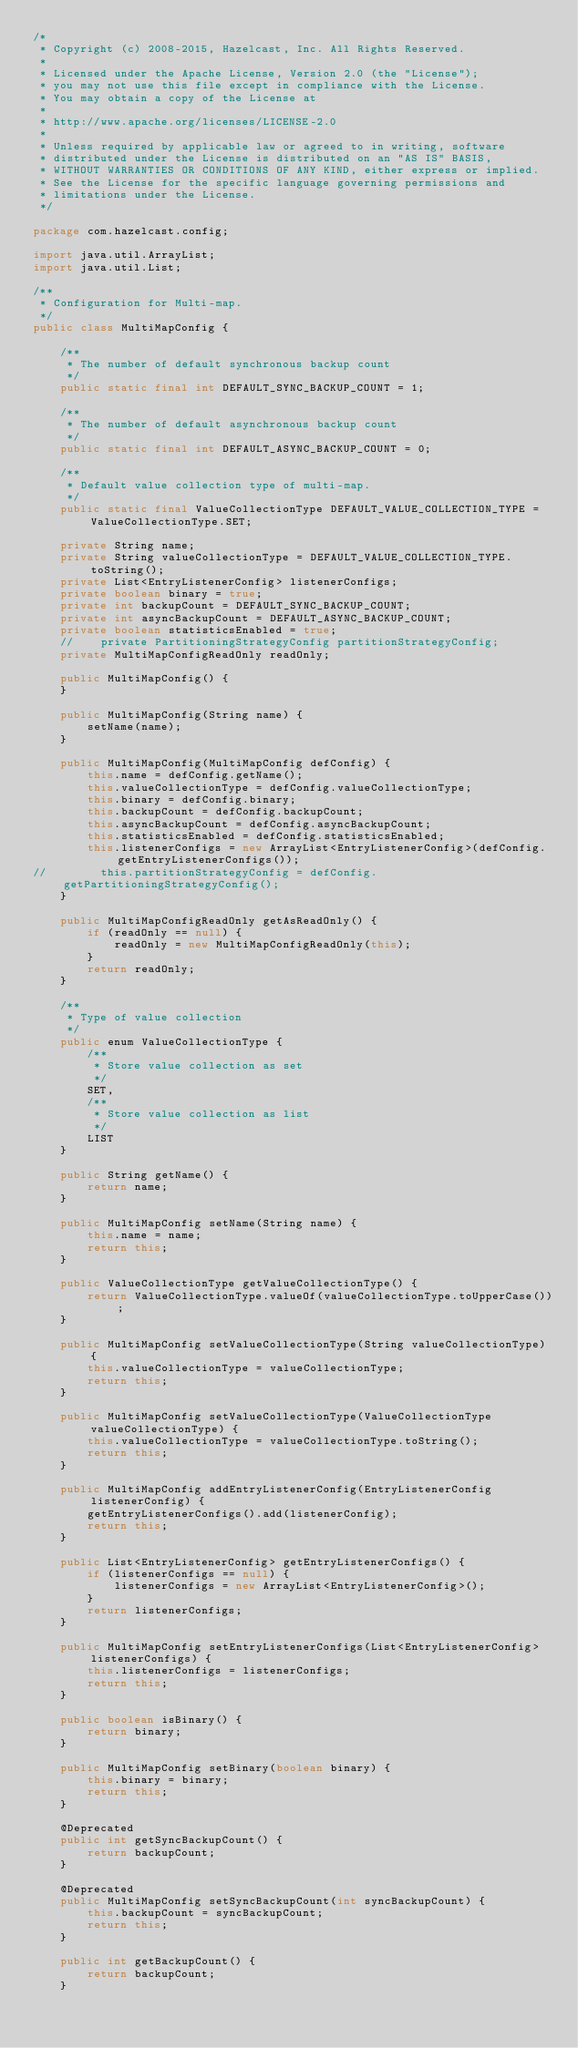<code> <loc_0><loc_0><loc_500><loc_500><_Java_>/*
 * Copyright (c) 2008-2015, Hazelcast, Inc. All Rights Reserved.
 *
 * Licensed under the Apache License, Version 2.0 (the "License");
 * you may not use this file except in compliance with the License.
 * You may obtain a copy of the License at
 *
 * http://www.apache.org/licenses/LICENSE-2.0
 *
 * Unless required by applicable law or agreed to in writing, software
 * distributed under the License is distributed on an "AS IS" BASIS,
 * WITHOUT WARRANTIES OR CONDITIONS OF ANY KIND, either express or implied.
 * See the License for the specific language governing permissions and
 * limitations under the License.
 */

package com.hazelcast.config;

import java.util.ArrayList;
import java.util.List;

/**
 * Configuration for Multi-map.
 */
public class MultiMapConfig {

    /**
     * The number of default synchronous backup count
     */
    public static final int DEFAULT_SYNC_BACKUP_COUNT = 1;

    /**
     * The number of default asynchronous backup count
     */
    public static final int DEFAULT_ASYNC_BACKUP_COUNT = 0;

    /**
     * Default value collection type of multi-map.
     */
    public static final ValueCollectionType DEFAULT_VALUE_COLLECTION_TYPE = ValueCollectionType.SET;

    private String name;
    private String valueCollectionType = DEFAULT_VALUE_COLLECTION_TYPE.toString();
    private List<EntryListenerConfig> listenerConfigs;
    private boolean binary = true;
    private int backupCount = DEFAULT_SYNC_BACKUP_COUNT;
    private int asyncBackupCount = DEFAULT_ASYNC_BACKUP_COUNT;
    private boolean statisticsEnabled = true;
    //    private PartitioningStrategyConfig partitionStrategyConfig;
    private MultiMapConfigReadOnly readOnly;

    public MultiMapConfig() {
    }

    public MultiMapConfig(String name) {
        setName(name);
    }

    public MultiMapConfig(MultiMapConfig defConfig) {
        this.name = defConfig.getName();
        this.valueCollectionType = defConfig.valueCollectionType;
        this.binary = defConfig.binary;
        this.backupCount = defConfig.backupCount;
        this.asyncBackupCount = defConfig.asyncBackupCount;
        this.statisticsEnabled = defConfig.statisticsEnabled;
        this.listenerConfigs = new ArrayList<EntryListenerConfig>(defConfig.getEntryListenerConfigs());
//        this.partitionStrategyConfig = defConfig.getPartitioningStrategyConfig();
    }

    public MultiMapConfigReadOnly getAsReadOnly() {
        if (readOnly == null) {
            readOnly = new MultiMapConfigReadOnly(this);
        }
        return readOnly;
    }

    /**
     * Type of value collection
     */
    public enum ValueCollectionType {
        /**
         * Store value collection as set
         */
        SET,
        /**
         * Store value collection as list
         */
        LIST
    }

    public String getName() {
        return name;
    }

    public MultiMapConfig setName(String name) {
        this.name = name;
        return this;
    }

    public ValueCollectionType getValueCollectionType() {
        return ValueCollectionType.valueOf(valueCollectionType.toUpperCase());
    }

    public MultiMapConfig setValueCollectionType(String valueCollectionType) {
        this.valueCollectionType = valueCollectionType;
        return this;
    }

    public MultiMapConfig setValueCollectionType(ValueCollectionType valueCollectionType) {
        this.valueCollectionType = valueCollectionType.toString();
        return this;
    }

    public MultiMapConfig addEntryListenerConfig(EntryListenerConfig listenerConfig) {
        getEntryListenerConfigs().add(listenerConfig);
        return this;
    }

    public List<EntryListenerConfig> getEntryListenerConfigs() {
        if (listenerConfigs == null) {
            listenerConfigs = new ArrayList<EntryListenerConfig>();
        }
        return listenerConfigs;
    }

    public MultiMapConfig setEntryListenerConfigs(List<EntryListenerConfig> listenerConfigs) {
        this.listenerConfigs = listenerConfigs;
        return this;
    }

    public boolean isBinary() {
        return binary;
    }

    public MultiMapConfig setBinary(boolean binary) {
        this.binary = binary;
        return this;
    }

    @Deprecated
    public int getSyncBackupCount() {
        return backupCount;
    }

    @Deprecated
    public MultiMapConfig setSyncBackupCount(int syncBackupCount) {
        this.backupCount = syncBackupCount;
        return this;
    }

    public int getBackupCount() {
        return backupCount;
    }
</code> 